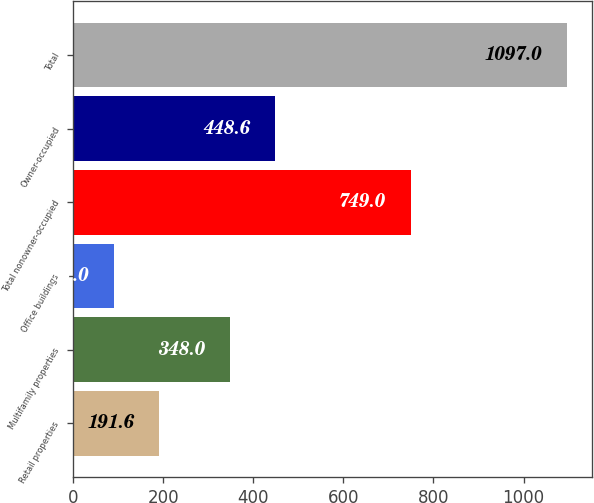Convert chart to OTSL. <chart><loc_0><loc_0><loc_500><loc_500><bar_chart><fcel>Retail properties<fcel>Multifamily properties<fcel>Office buildings<fcel>Total nonowner-occupied<fcel>Owner-occupied<fcel>Total<nl><fcel>191.6<fcel>348<fcel>91<fcel>749<fcel>448.6<fcel>1097<nl></chart> 